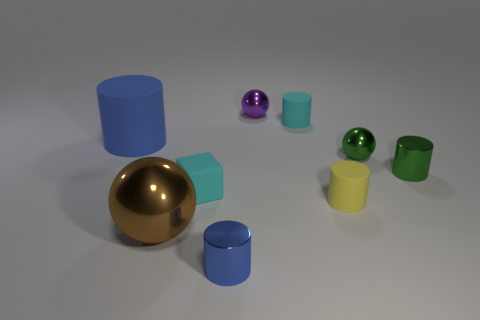Do the tiny cyan object in front of the green metal ball and the blue cylinder that is in front of the cyan matte block have the same material?
Give a very brief answer. No. What number of objects are either metal objects that are behind the brown metal sphere or tiny matte cylinders that are in front of the rubber cube?
Make the answer very short. 4. What number of small green metallic cylinders are there?
Offer a terse response. 1. Are there any red objects that have the same size as the blue metal object?
Offer a very short reply. No. Is the material of the tiny blue thing the same as the cyan object that is in front of the green cylinder?
Offer a very short reply. No. What is the sphere to the left of the blue shiny thing made of?
Provide a succinct answer. Metal. What is the size of the brown thing?
Keep it short and to the point. Large. Do the cyan object that is on the right side of the tiny purple thing and the blue cylinder to the right of the small cyan matte cube have the same size?
Your response must be concise. Yes. The yellow object that is the same shape as the large blue object is what size?
Keep it short and to the point. Small. Does the brown ball have the same size as the cube to the left of the small purple metal sphere?
Offer a terse response. No. 